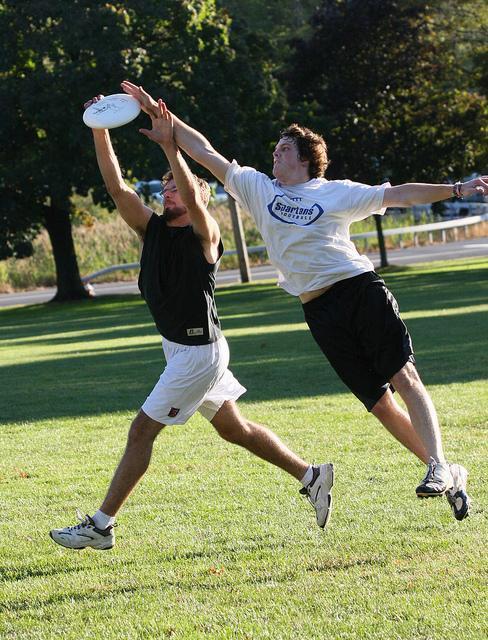How many people are shown wearing hats?
Give a very brief answer. 0. How many people are visible?
Give a very brief answer. 2. How many chairs are behind the pole?
Give a very brief answer. 0. 